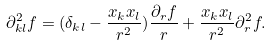Convert formula to latex. <formula><loc_0><loc_0><loc_500><loc_500>\partial ^ { 2 } _ { k l } f = ( \delta _ { k l } - \frac { x _ { k } x _ { l } } { r ^ { 2 } } ) \frac { \partial _ { r } f } { r } + \frac { x _ { k } x _ { l } } { r ^ { 2 } } \partial ^ { 2 } _ { r } f .</formula> 